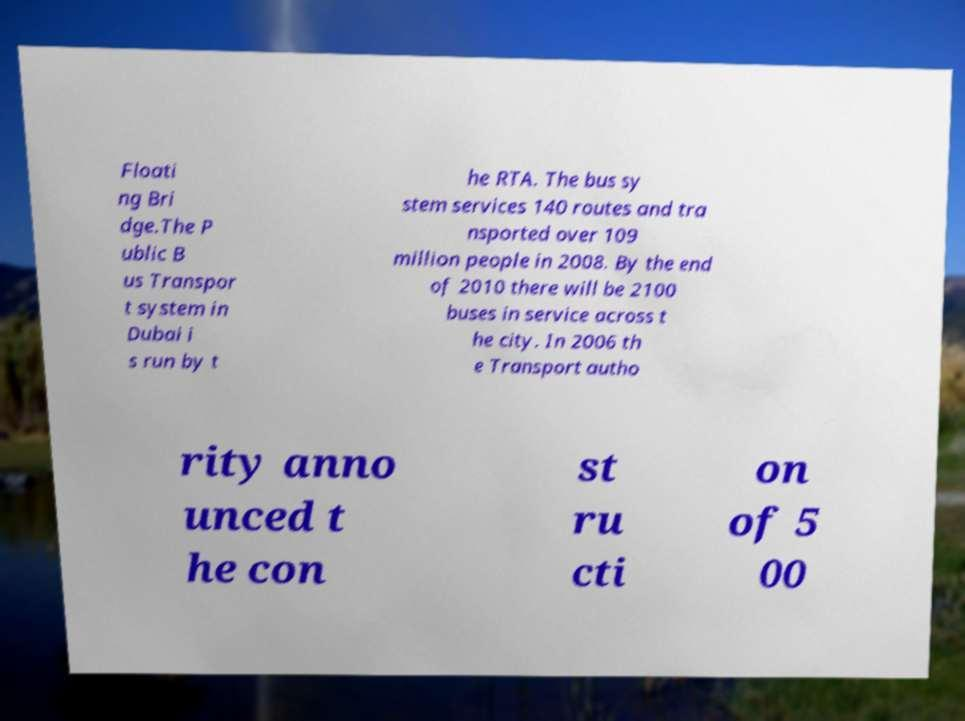Please identify and transcribe the text found in this image. Floati ng Bri dge.The P ublic B us Transpor t system in Dubai i s run by t he RTA. The bus sy stem services 140 routes and tra nsported over 109 million people in 2008. By the end of 2010 there will be 2100 buses in service across t he city. In 2006 th e Transport autho rity anno unced t he con st ru cti on of 5 00 